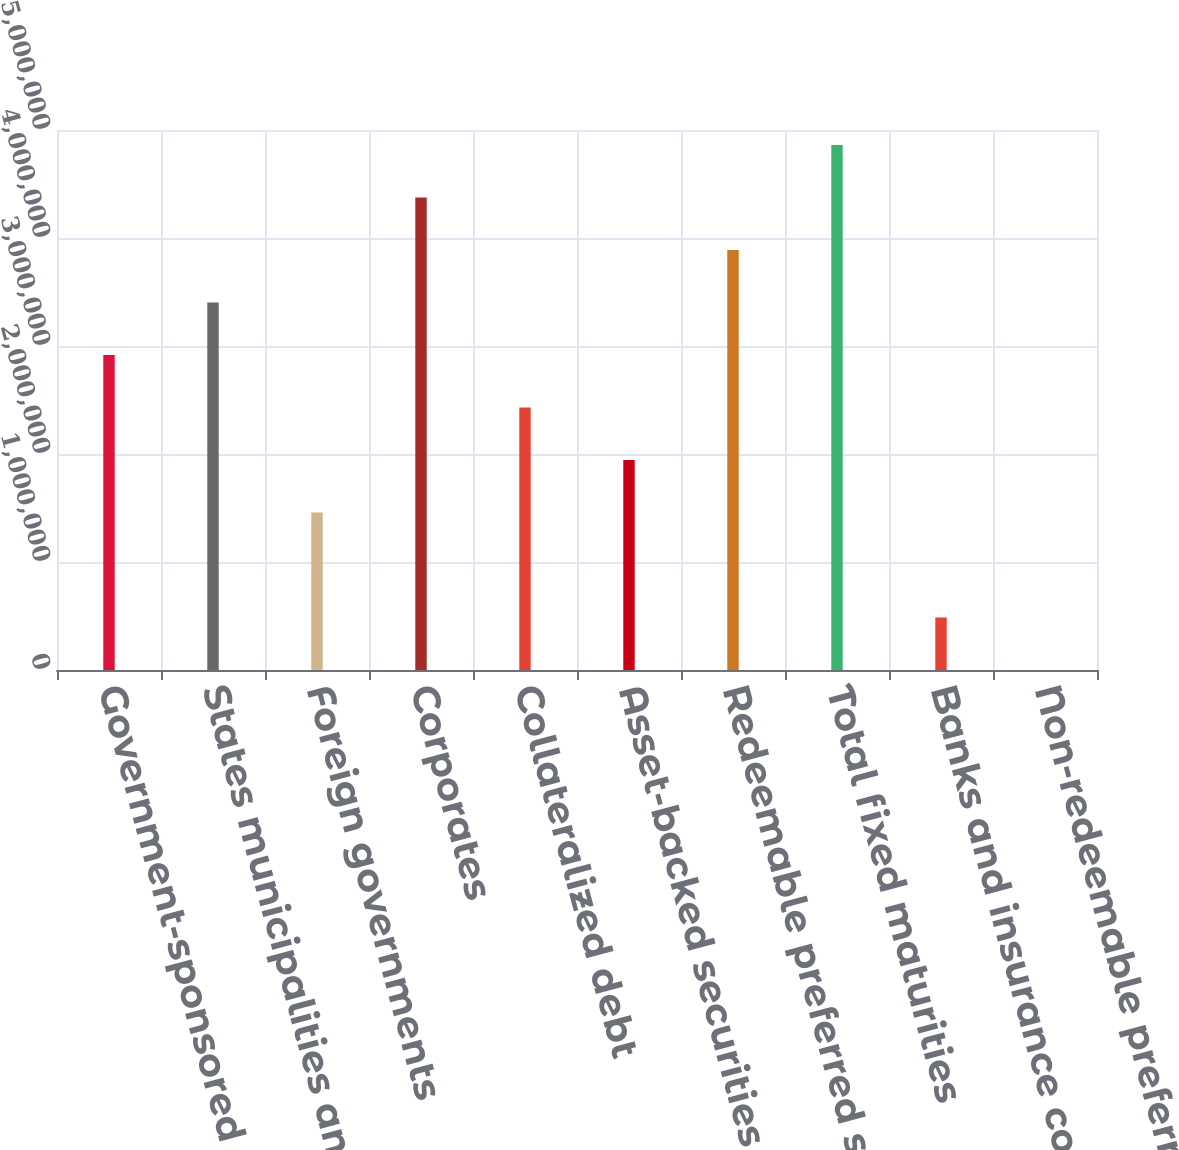Convert chart to OTSL. <chart><loc_0><loc_0><loc_500><loc_500><bar_chart><fcel>Government-sponsored<fcel>States municipalities and<fcel>Foreign governments<fcel>Corporates<fcel>Collateralized debt<fcel>Asset-backed securities<fcel>Redeemable preferred stocks<fcel>Total fixed maturities<fcel>Banks and insurance companies<fcel>Non-redeemable preferred<nl><fcel>2.91723e+06<fcel>3.40343e+06<fcel>1.45864e+06<fcel>4.37582e+06<fcel>2.43104e+06<fcel>1.94484e+06<fcel>3.88963e+06<fcel>4.86202e+06<fcel>486250<fcel>54<nl></chart> 